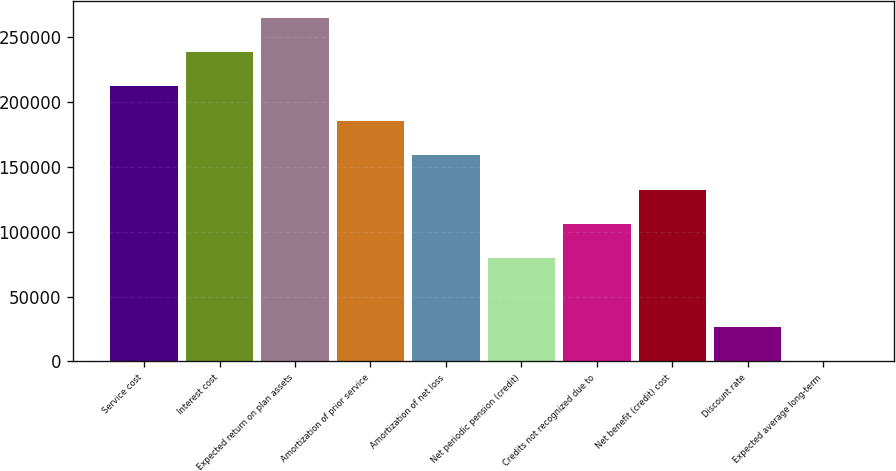Convert chart to OTSL. <chart><loc_0><loc_0><loc_500><loc_500><bar_chart><fcel>Service cost<fcel>Interest cost<fcel>Expected return on plan assets<fcel>Amortization of prior service<fcel>Amortization of net loss<fcel>Net periodic pension (credit)<fcel>Credits not recognized due to<fcel>Net benefit (credit) cost<fcel>Discount rate<fcel>Expected average long-term<nl><fcel>211866<fcel>238348<fcel>264831<fcel>185383<fcel>158900<fcel>79452.1<fcel>105935<fcel>132418<fcel>26486.7<fcel>4<nl></chart> 